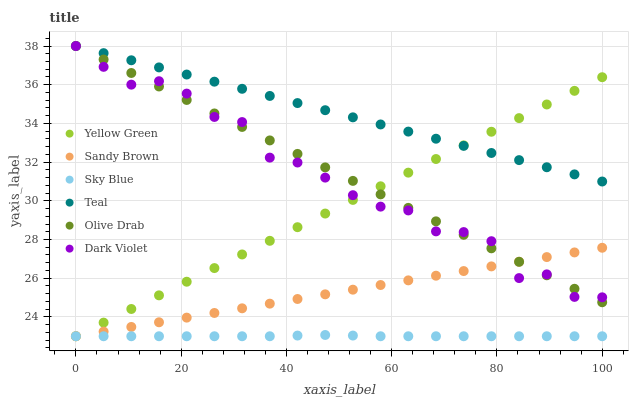Does Sky Blue have the minimum area under the curve?
Answer yes or no. Yes. Does Teal have the maximum area under the curve?
Answer yes or no. Yes. Does Dark Violet have the minimum area under the curve?
Answer yes or no. No. Does Dark Violet have the maximum area under the curve?
Answer yes or no. No. Is Teal the smoothest?
Answer yes or no. Yes. Is Dark Violet the roughest?
Answer yes or no. Yes. Is Dark Violet the smoothest?
Answer yes or no. No. Is Teal the roughest?
Answer yes or no. No. Does Yellow Green have the lowest value?
Answer yes or no. Yes. Does Dark Violet have the lowest value?
Answer yes or no. No. Does Olive Drab have the highest value?
Answer yes or no. Yes. Does Sky Blue have the highest value?
Answer yes or no. No. Is Sky Blue less than Teal?
Answer yes or no. Yes. Is Teal greater than Sky Blue?
Answer yes or no. Yes. Does Dark Violet intersect Sandy Brown?
Answer yes or no. Yes. Is Dark Violet less than Sandy Brown?
Answer yes or no. No. Is Dark Violet greater than Sandy Brown?
Answer yes or no. No. Does Sky Blue intersect Teal?
Answer yes or no. No. 